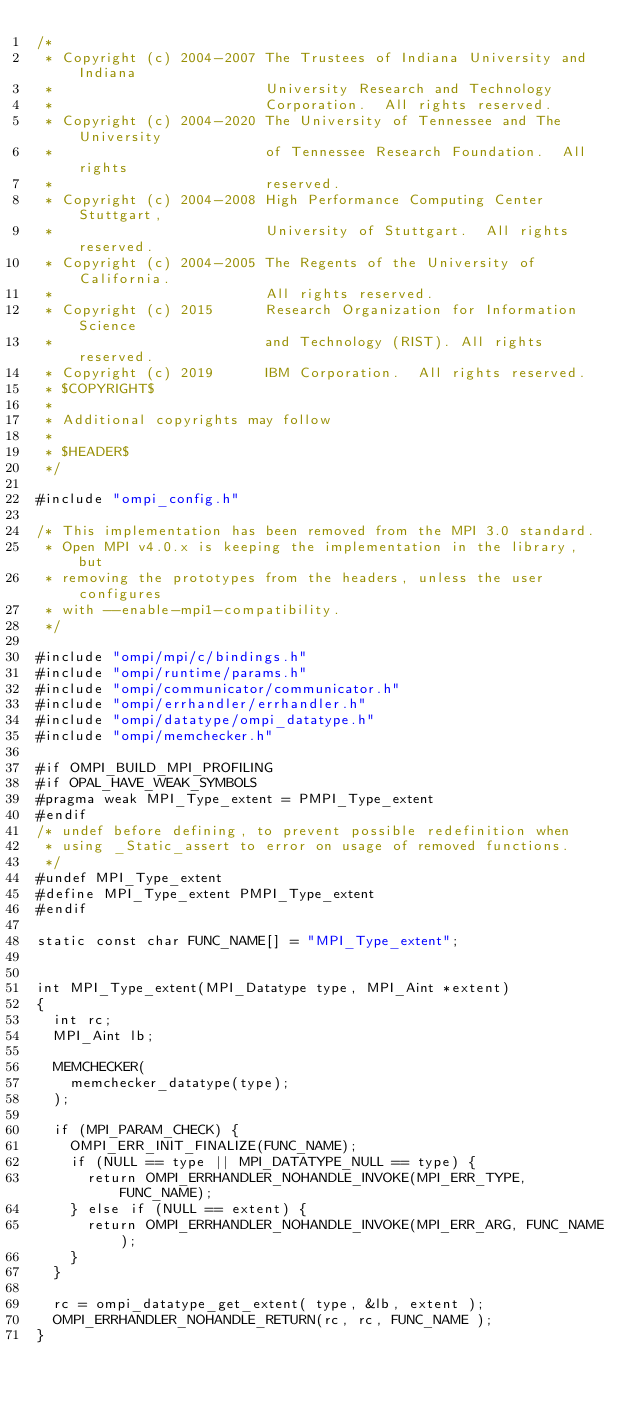<code> <loc_0><loc_0><loc_500><loc_500><_C_>/*
 * Copyright (c) 2004-2007 The Trustees of Indiana University and Indiana
 *                         University Research and Technology
 *                         Corporation.  All rights reserved.
 * Copyright (c) 2004-2020 The University of Tennessee and The University
 *                         of Tennessee Research Foundation.  All rights
 *                         reserved.
 * Copyright (c) 2004-2008 High Performance Computing Center Stuttgart,
 *                         University of Stuttgart.  All rights reserved.
 * Copyright (c) 2004-2005 The Regents of the University of California.
 *                         All rights reserved.
 * Copyright (c) 2015      Research Organization for Information Science
 *                         and Technology (RIST). All rights reserved.
 * Copyright (c) 2019      IBM Corporation.  All rights reserved.
 * $COPYRIGHT$
 *
 * Additional copyrights may follow
 *
 * $HEADER$
 */

#include "ompi_config.h"

/* This implementation has been removed from the MPI 3.0 standard.
 * Open MPI v4.0.x is keeping the implementation in the library, but
 * removing the prototypes from the headers, unless the user configures
 * with --enable-mpi1-compatibility.
 */

#include "ompi/mpi/c/bindings.h"
#include "ompi/runtime/params.h"
#include "ompi/communicator/communicator.h"
#include "ompi/errhandler/errhandler.h"
#include "ompi/datatype/ompi_datatype.h"
#include "ompi/memchecker.h"

#if OMPI_BUILD_MPI_PROFILING
#if OPAL_HAVE_WEAK_SYMBOLS
#pragma weak MPI_Type_extent = PMPI_Type_extent
#endif
/* undef before defining, to prevent possible redefinition when
 * using _Static_assert to error on usage of removed functions.
 */
#undef MPI_Type_extent
#define MPI_Type_extent PMPI_Type_extent
#endif

static const char FUNC_NAME[] = "MPI_Type_extent";


int MPI_Type_extent(MPI_Datatype type, MPI_Aint *extent)
{
  int rc;
  MPI_Aint lb;

  MEMCHECKER(
    memchecker_datatype(type);
  );

  if (MPI_PARAM_CHECK) {
    OMPI_ERR_INIT_FINALIZE(FUNC_NAME);
    if (NULL == type || MPI_DATATYPE_NULL == type) {
      return OMPI_ERRHANDLER_NOHANDLE_INVOKE(MPI_ERR_TYPE, FUNC_NAME);
    } else if (NULL == extent) {
      return OMPI_ERRHANDLER_NOHANDLE_INVOKE(MPI_ERR_ARG, FUNC_NAME);
    }
  }

  rc = ompi_datatype_get_extent( type, &lb, extent );
  OMPI_ERRHANDLER_NOHANDLE_RETURN(rc, rc, FUNC_NAME );
}
</code> 